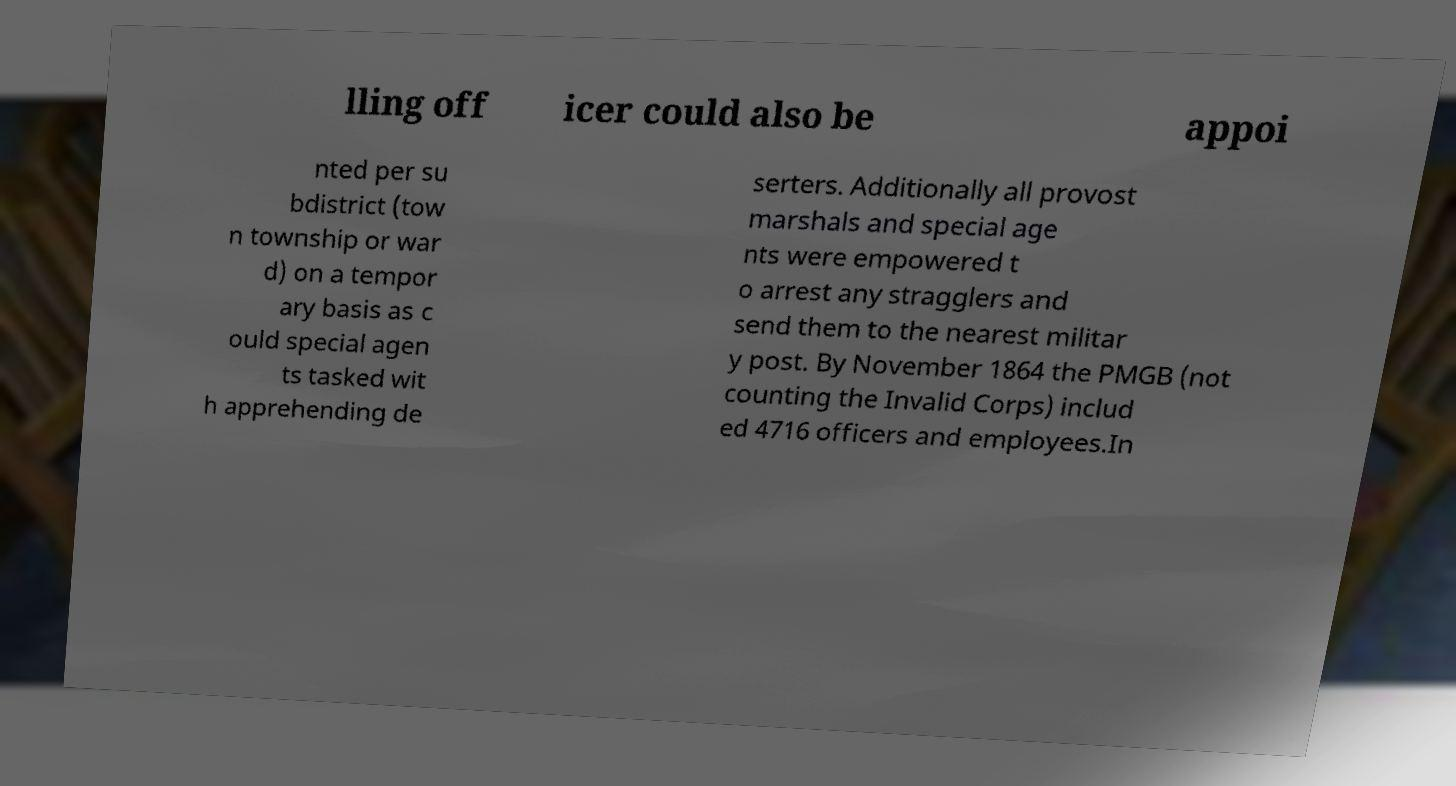What messages or text are displayed in this image? I need them in a readable, typed format. lling off icer could also be appoi nted per su bdistrict (tow n township or war d) on a tempor ary basis as c ould special agen ts tasked wit h apprehending de serters. Additionally all provost marshals and special age nts were empowered t o arrest any stragglers and send them to the nearest militar y post. By November 1864 the PMGB (not counting the Invalid Corps) includ ed 4716 officers and employees.In 